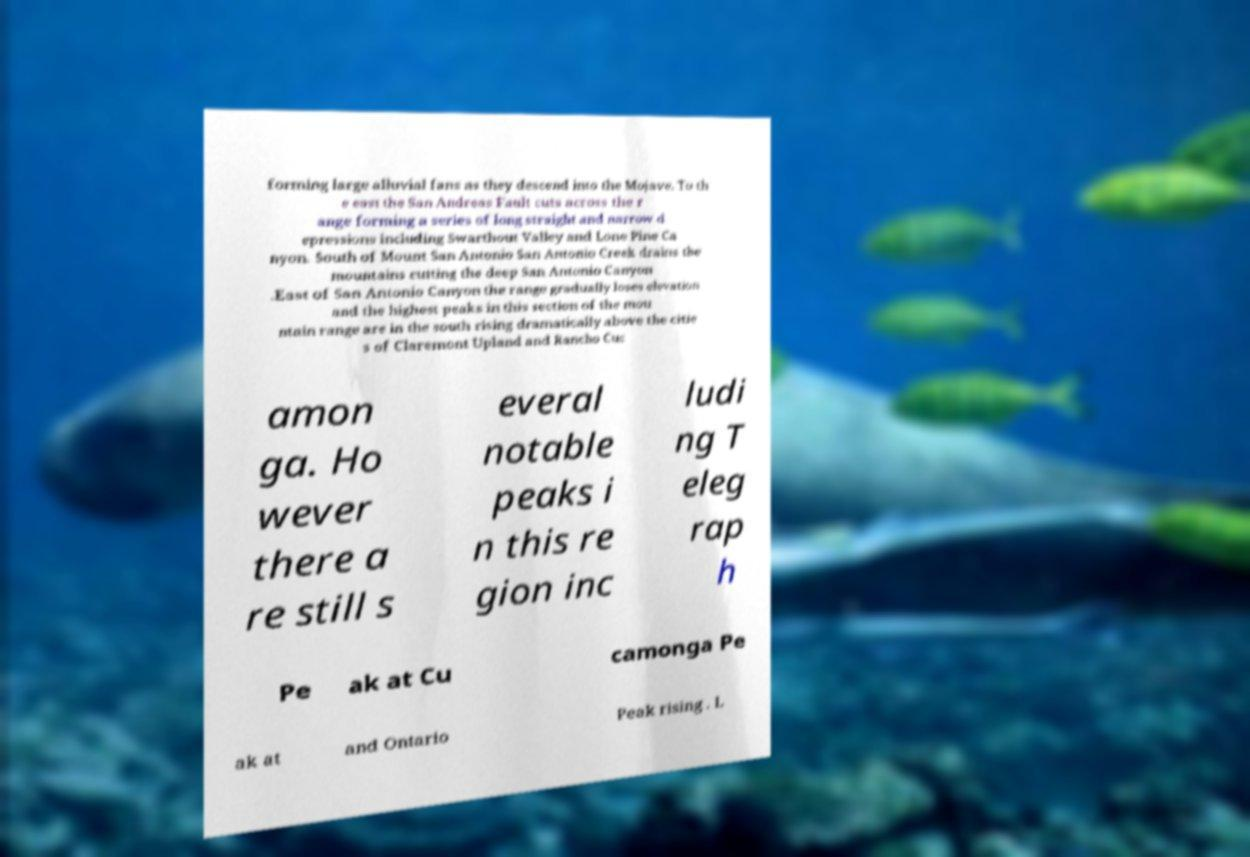Could you assist in decoding the text presented in this image and type it out clearly? forming large alluvial fans as they descend into the Mojave. To th e east the San Andreas Fault cuts across the r ange forming a series of long straight and narrow d epressions including Swarthout Valley and Lone Pine Ca nyon. South of Mount San Antonio San Antonio Creek drains the mountains cutting the deep San Antonio Canyon .East of San Antonio Canyon the range gradually loses elevation and the highest peaks in this section of the mou ntain range are in the south rising dramatically above the citie s of Claremont Upland and Rancho Cuc amon ga. Ho wever there a re still s everal notable peaks i n this re gion inc ludi ng T eleg rap h Pe ak at Cu camonga Pe ak at and Ontario Peak rising . L 